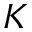<formula> <loc_0><loc_0><loc_500><loc_500>K</formula> 